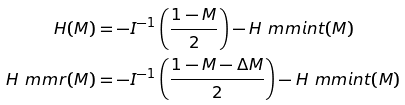Convert formula to latex. <formula><loc_0><loc_0><loc_500><loc_500>H ( M ) & = - I ^ { - 1 } \left ( \frac { 1 - M } { 2 } \right ) - H _ { \ } m m { i n t } ( M ) \\ H _ { \ } m m { r } ( M ) & = - I ^ { - 1 } \left ( \frac { 1 - M - \Delta M } { 2 } \right ) - H _ { \ } m m { i n t } ( M )</formula> 